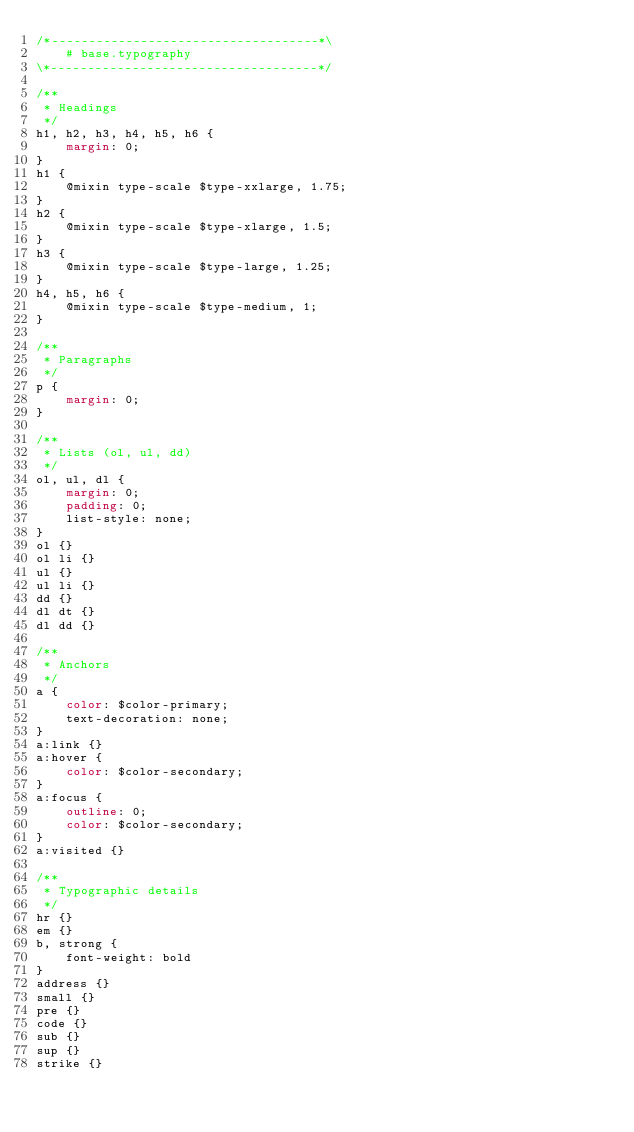<code> <loc_0><loc_0><loc_500><loc_500><_CSS_>/*------------------------------------*\
    # base.typography
\*------------------------------------*/

/**
 * Headings
 */
h1, h2, h3, h4, h5, h6 {
    margin: 0;
}
h1 {
    @mixin type-scale $type-xxlarge, 1.75;
}
h2 {
    @mixin type-scale $type-xlarge, 1.5;
}
h3 {
    @mixin type-scale $type-large, 1.25;
}
h4, h5, h6 {
    @mixin type-scale $type-medium, 1;
}

/**
 * Paragraphs
 */
p {
    margin: 0;
}

/**
 * Lists (ol, ul, dd)
 */
ol, ul, dl {
    margin: 0;
    padding: 0;
    list-style: none;
}
ol {}
ol li {}
ul {}
ul li {}
dd {}
dl dt {}
dl dd {}

/**
 * Anchors
 */
a {
    color: $color-primary;
    text-decoration: none;
}
a:link {}
a:hover {
    color: $color-secondary;
}
a:focus {
    outline: 0;
    color: $color-secondary;
}
a:visited {}

/**
 * Typographic details
 */
hr {}
em {}
b, strong {
    font-weight: bold
}
address {}
small {}
pre {}
code {}
sub {}
sup {}
strike {}
</code> 